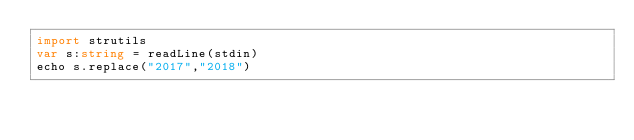Convert code to text. <code><loc_0><loc_0><loc_500><loc_500><_Nim_>import strutils
var s:string = readLine(stdin)
echo s.replace("2017","2018")</code> 